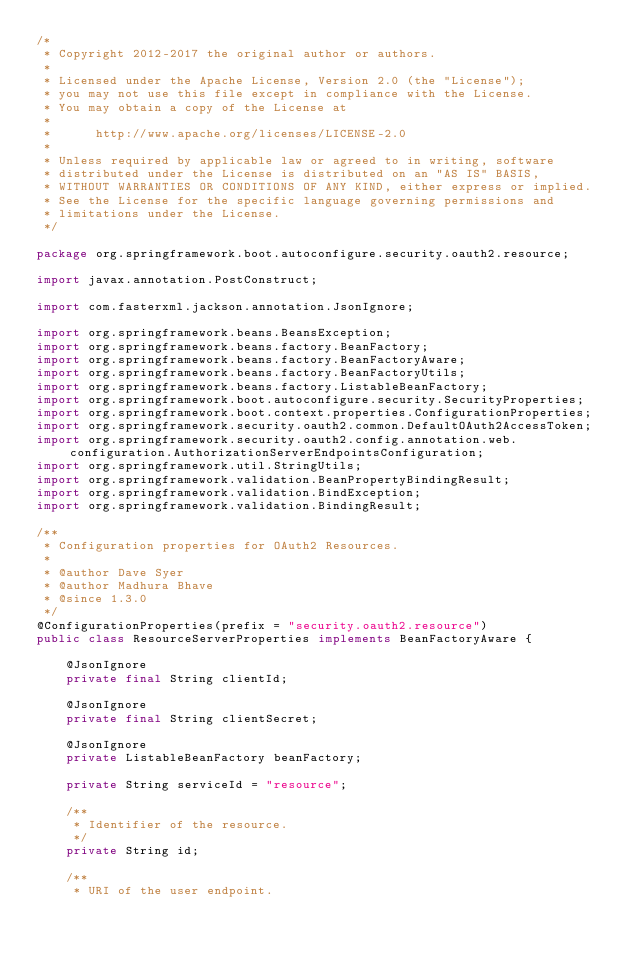Convert code to text. <code><loc_0><loc_0><loc_500><loc_500><_Java_>/*
 * Copyright 2012-2017 the original author or authors.
 *
 * Licensed under the Apache License, Version 2.0 (the "License");
 * you may not use this file except in compliance with the License.
 * You may obtain a copy of the License at
 *
 *      http://www.apache.org/licenses/LICENSE-2.0
 *
 * Unless required by applicable law or agreed to in writing, software
 * distributed under the License is distributed on an "AS IS" BASIS,
 * WITHOUT WARRANTIES OR CONDITIONS OF ANY KIND, either express or implied.
 * See the License for the specific language governing permissions and
 * limitations under the License.
 */

package org.springframework.boot.autoconfigure.security.oauth2.resource;

import javax.annotation.PostConstruct;

import com.fasterxml.jackson.annotation.JsonIgnore;

import org.springframework.beans.BeansException;
import org.springframework.beans.factory.BeanFactory;
import org.springframework.beans.factory.BeanFactoryAware;
import org.springframework.beans.factory.BeanFactoryUtils;
import org.springframework.beans.factory.ListableBeanFactory;
import org.springframework.boot.autoconfigure.security.SecurityProperties;
import org.springframework.boot.context.properties.ConfigurationProperties;
import org.springframework.security.oauth2.common.DefaultOAuth2AccessToken;
import org.springframework.security.oauth2.config.annotation.web.configuration.AuthorizationServerEndpointsConfiguration;
import org.springframework.util.StringUtils;
import org.springframework.validation.BeanPropertyBindingResult;
import org.springframework.validation.BindException;
import org.springframework.validation.BindingResult;

/**
 * Configuration properties for OAuth2 Resources.
 *
 * @author Dave Syer
 * @author Madhura Bhave
 * @since 1.3.0
 */
@ConfigurationProperties(prefix = "security.oauth2.resource")
public class ResourceServerProperties implements BeanFactoryAware {

	@JsonIgnore
	private final String clientId;

	@JsonIgnore
	private final String clientSecret;

	@JsonIgnore
	private ListableBeanFactory beanFactory;

	private String serviceId = "resource";

	/**
	 * Identifier of the resource.
	 */
	private String id;

	/**
	 * URI of the user endpoint.</code> 